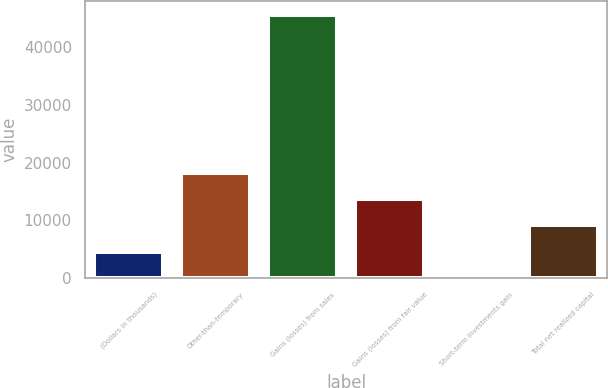Convert chart. <chart><loc_0><loc_0><loc_500><loc_500><bar_chart><fcel>(Dollars in thousands)<fcel>Other-than-temporary<fcel>Gains (losses) from sales<fcel>Gains (losses) from fair value<fcel>Short-term investments gain<fcel>Total net realized capital<nl><fcel>4602.6<fcel>18290.4<fcel>45666<fcel>13727.8<fcel>40<fcel>9165.2<nl></chart> 